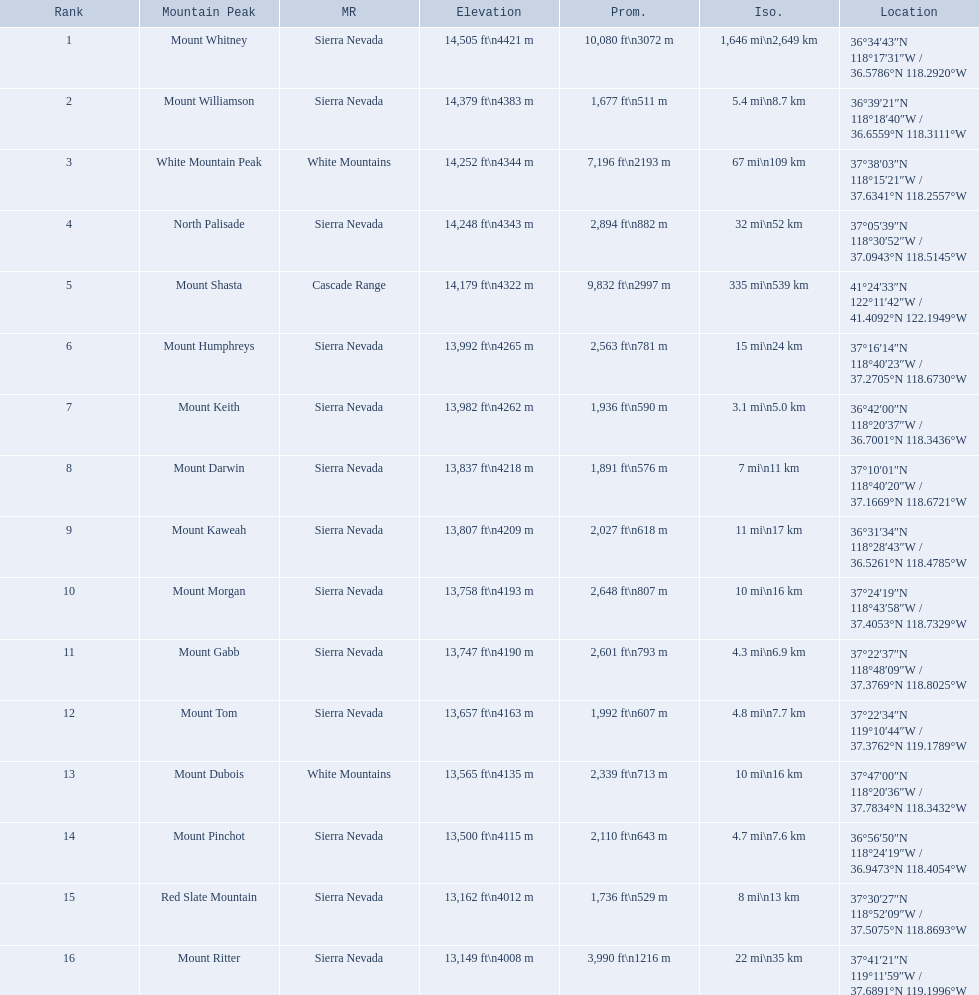What are the peaks in california? Mount Whitney, Mount Williamson, White Mountain Peak, North Palisade, Mount Shasta, Mount Humphreys, Mount Keith, Mount Darwin, Mount Kaweah, Mount Morgan, Mount Gabb, Mount Tom, Mount Dubois, Mount Pinchot, Red Slate Mountain, Mount Ritter. What are the peaks in sierra nevada, california? Mount Whitney, Mount Williamson, North Palisade, Mount Humphreys, Mount Keith, Mount Darwin, Mount Kaweah, Mount Morgan, Mount Gabb, Mount Tom, Mount Pinchot, Red Slate Mountain, Mount Ritter. What are the heights of the peaks in sierra nevada? 14,505 ft\n4421 m, 14,379 ft\n4383 m, 14,248 ft\n4343 m, 13,992 ft\n4265 m, 13,982 ft\n4262 m, 13,837 ft\n4218 m, 13,807 ft\n4209 m, 13,758 ft\n4193 m, 13,747 ft\n4190 m, 13,657 ft\n4163 m, 13,500 ft\n4115 m, 13,162 ft\n4012 m, 13,149 ft\n4008 m. Which is the highest? Mount Whitney. 